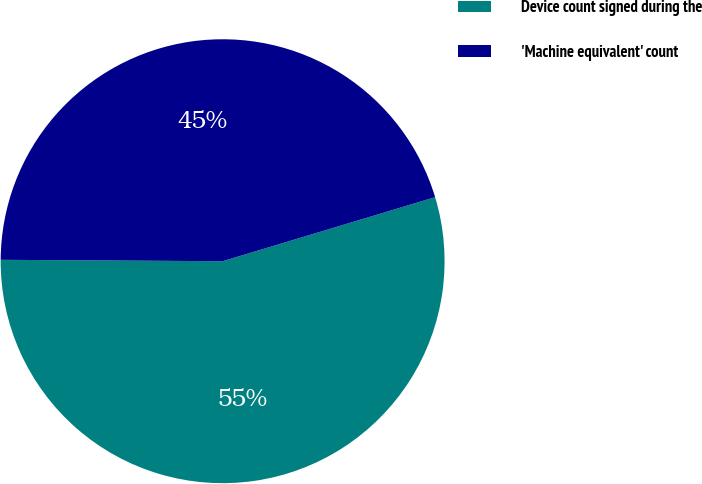Convert chart. <chart><loc_0><loc_0><loc_500><loc_500><pie_chart><fcel>Device count signed during the<fcel>'Machine equivalent' count<nl><fcel>54.76%<fcel>45.24%<nl></chart> 